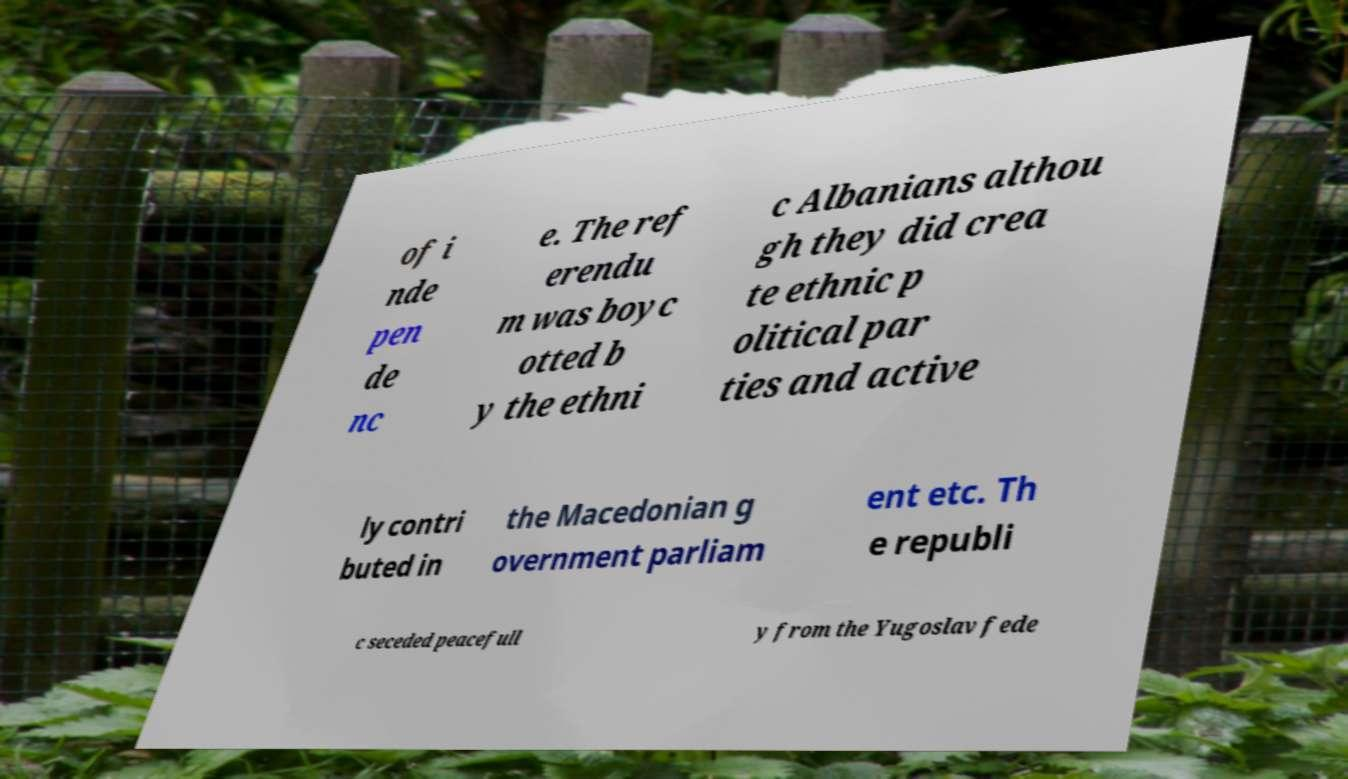Please read and relay the text visible in this image. What does it say? of i nde pen de nc e. The ref erendu m was boyc otted b y the ethni c Albanians althou gh they did crea te ethnic p olitical par ties and active ly contri buted in the Macedonian g overnment parliam ent etc. Th e republi c seceded peacefull y from the Yugoslav fede 